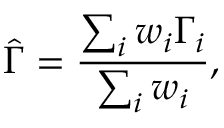Convert formula to latex. <formula><loc_0><loc_0><loc_500><loc_500>\hat { \Gamma } = \frac { \sum _ { i } w _ { i } \Gamma _ { i } } { \sum _ { i } w _ { i } } ,</formula> 